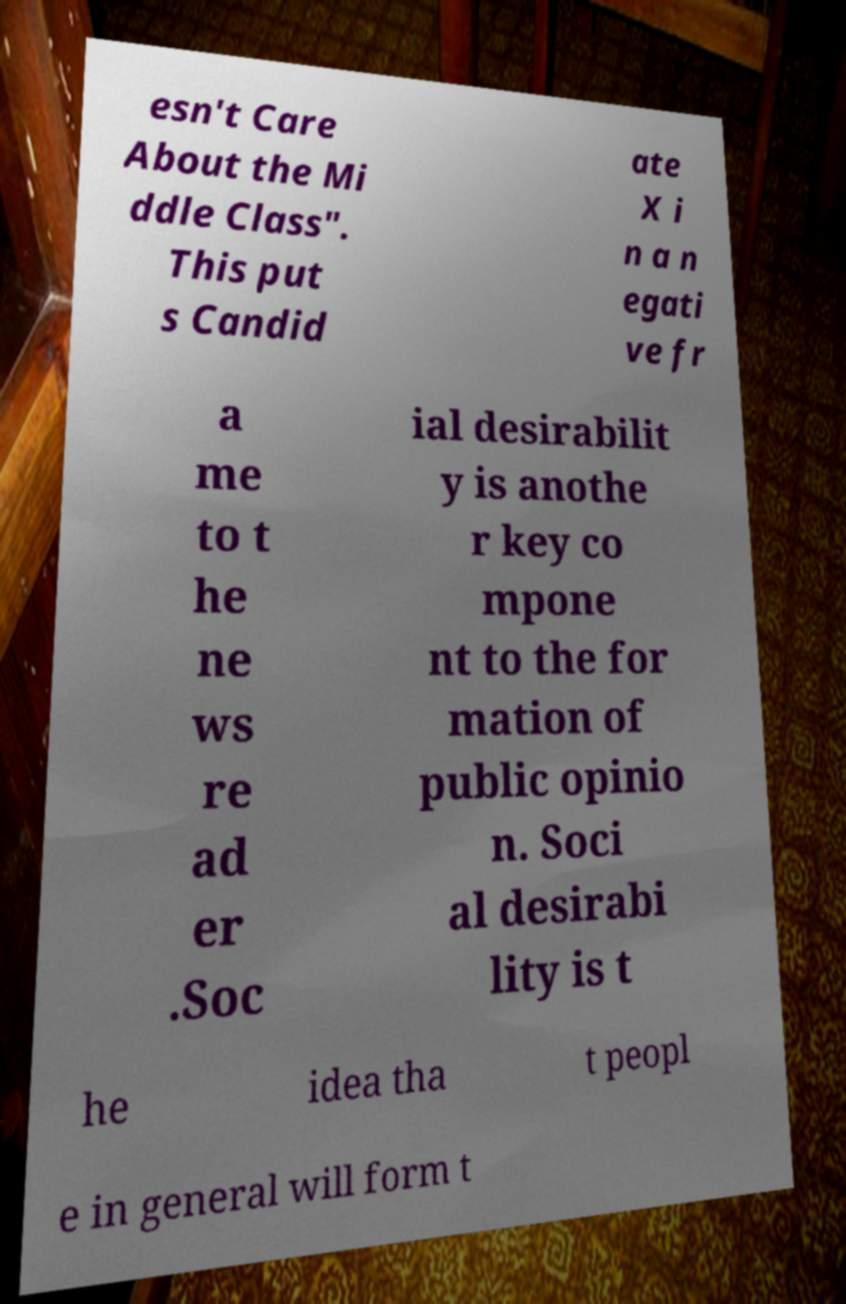Could you extract and type out the text from this image? esn't Care About the Mi ddle Class". This put s Candid ate X i n a n egati ve fr a me to t he ne ws re ad er .Soc ial desirabilit y is anothe r key co mpone nt to the for mation of public opinio n. Soci al desirabi lity is t he idea tha t peopl e in general will form t 